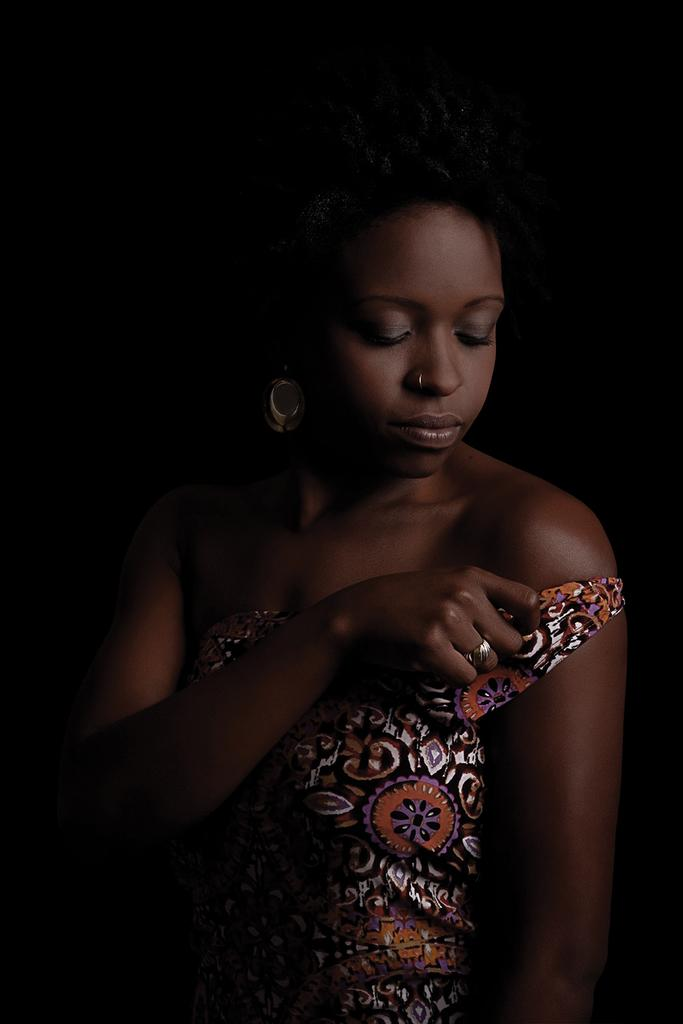Who is the main subject in the image? There is a woman in the image. What is the woman wearing in the image? The woman is wearing an earring and a dress in the image. Can you describe the background of the image? The background of the image is dark. What type of destruction can be seen in the image? There is no destruction present in the image; it features a woman wearing an earring and a dress against a dark background. 